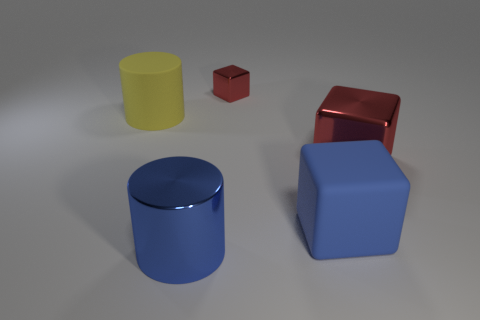Is the material of the small red object the same as the big yellow object?
Offer a terse response. No. What is the shape of the rubber thing that is in front of the thing that is left of the large blue metallic object?
Give a very brief answer. Cube. There is a blue object that is right of the blue cylinder; how many blue things are in front of it?
Ensure brevity in your answer.  1. What material is the object that is on the left side of the blue rubber cube and to the right of the big blue cylinder?
Offer a terse response. Metal. The red object that is the same size as the metallic cylinder is what shape?
Provide a succinct answer. Cube. What is the color of the object that is in front of the big matte object that is right of the shiny thing in front of the blue matte cube?
Make the answer very short. Blue. How many things are either metal objects left of the small block or small brown objects?
Give a very brief answer. 1. There is a blue cylinder that is the same size as the yellow cylinder; what material is it?
Keep it short and to the point. Metal. The big cylinder that is in front of the big rubber object that is behind the red object in front of the large rubber cylinder is made of what material?
Provide a succinct answer. Metal. The matte block is what color?
Your response must be concise. Blue. 